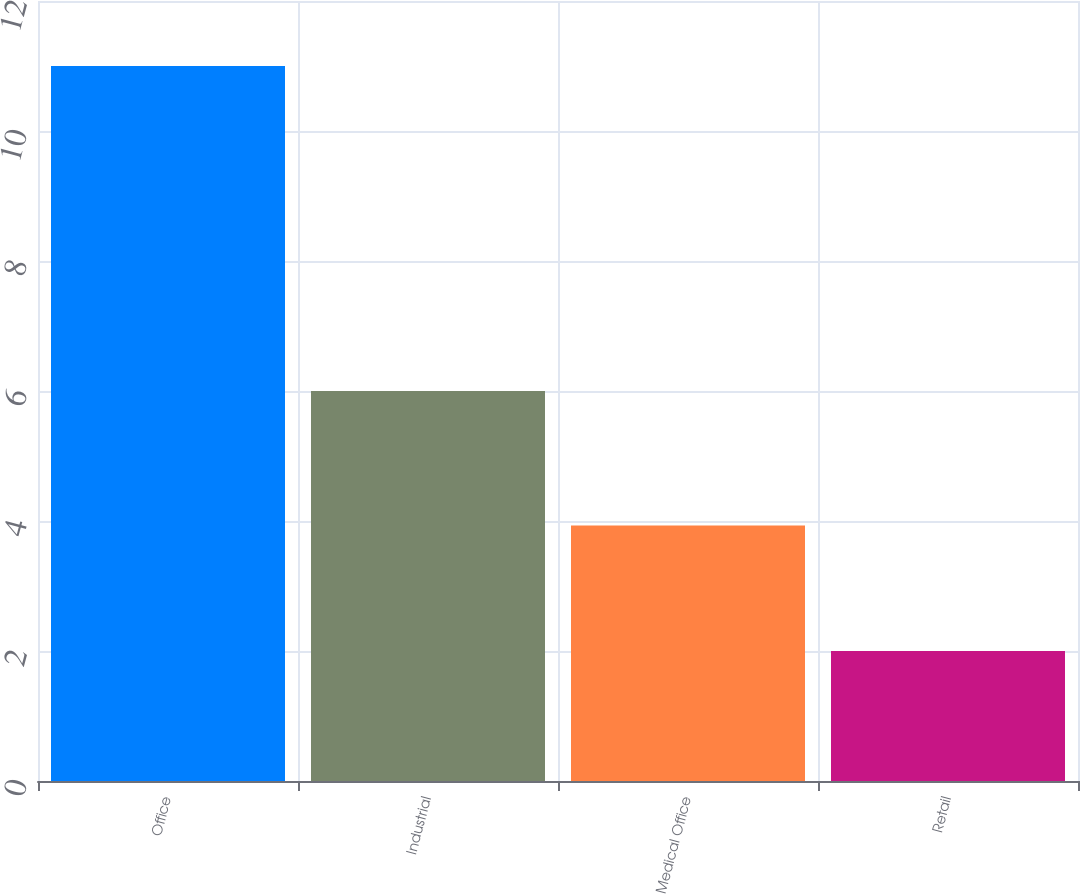Convert chart to OTSL. <chart><loc_0><loc_0><loc_500><loc_500><bar_chart><fcel>Office<fcel>Industrial<fcel>Medical Office<fcel>Retail<nl><fcel>11<fcel>6<fcel>3.93<fcel>2<nl></chart> 